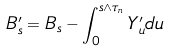Convert formula to latex. <formula><loc_0><loc_0><loc_500><loc_500>B ^ { \prime } _ { s } = B _ { s } - \int _ { 0 } ^ { s \wedge \tau _ { n } } Y ^ { \prime } _ { u } d u</formula> 